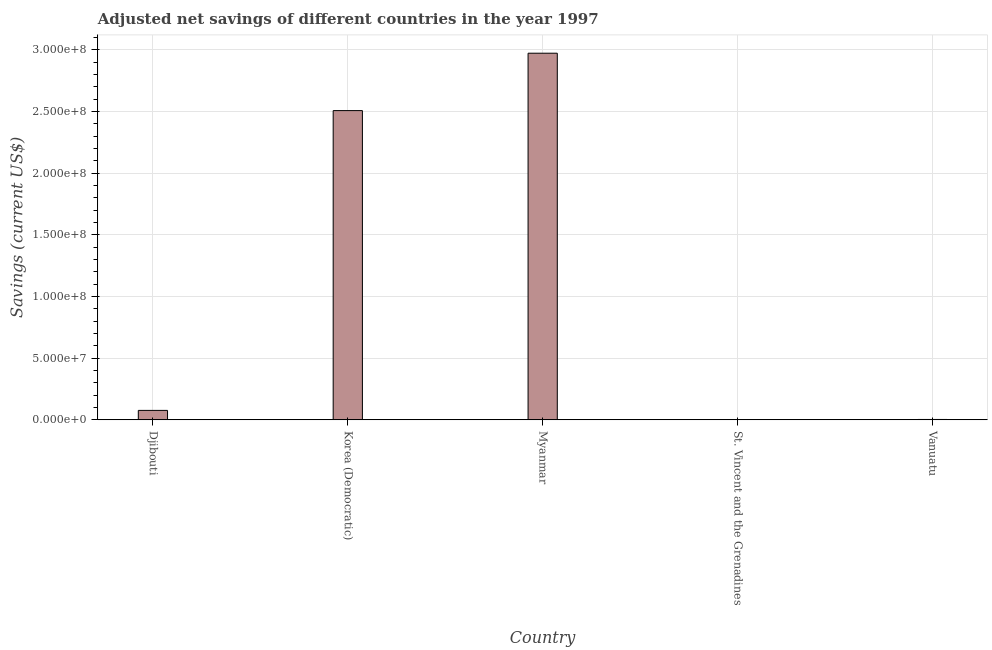What is the title of the graph?
Give a very brief answer. Adjusted net savings of different countries in the year 1997. What is the label or title of the Y-axis?
Your answer should be very brief. Savings (current US$). What is the adjusted net savings in Djibouti?
Give a very brief answer. 7.63e+06. Across all countries, what is the maximum adjusted net savings?
Provide a succinct answer. 2.97e+08. Across all countries, what is the minimum adjusted net savings?
Your response must be concise. 1.61e+05. In which country was the adjusted net savings maximum?
Your response must be concise. Myanmar. In which country was the adjusted net savings minimum?
Your answer should be compact. St. Vincent and the Grenadines. What is the sum of the adjusted net savings?
Provide a succinct answer. 5.56e+08. What is the difference between the adjusted net savings in Myanmar and St. Vincent and the Grenadines?
Your answer should be very brief. 2.97e+08. What is the average adjusted net savings per country?
Offer a very short reply. 1.11e+08. What is the median adjusted net savings?
Provide a short and direct response. 7.63e+06. What is the ratio of the adjusted net savings in Korea (Democratic) to that in Myanmar?
Your answer should be very brief. 0.84. What is the difference between the highest and the second highest adjusted net savings?
Offer a terse response. 4.65e+07. Is the sum of the adjusted net savings in Djibouti and St. Vincent and the Grenadines greater than the maximum adjusted net savings across all countries?
Give a very brief answer. No. What is the difference between the highest and the lowest adjusted net savings?
Your response must be concise. 2.97e+08. How many bars are there?
Offer a very short reply. 5. How many countries are there in the graph?
Give a very brief answer. 5. Are the values on the major ticks of Y-axis written in scientific E-notation?
Provide a succinct answer. Yes. What is the Savings (current US$) of Djibouti?
Give a very brief answer. 7.63e+06. What is the Savings (current US$) of Korea (Democratic)?
Ensure brevity in your answer.  2.51e+08. What is the Savings (current US$) of Myanmar?
Your answer should be very brief. 2.97e+08. What is the Savings (current US$) of St. Vincent and the Grenadines?
Make the answer very short. 1.61e+05. What is the Savings (current US$) in Vanuatu?
Offer a very short reply. 2.82e+05. What is the difference between the Savings (current US$) in Djibouti and Korea (Democratic)?
Provide a succinct answer. -2.43e+08. What is the difference between the Savings (current US$) in Djibouti and Myanmar?
Provide a short and direct response. -2.90e+08. What is the difference between the Savings (current US$) in Djibouti and St. Vincent and the Grenadines?
Your response must be concise. 7.46e+06. What is the difference between the Savings (current US$) in Djibouti and Vanuatu?
Ensure brevity in your answer.  7.34e+06. What is the difference between the Savings (current US$) in Korea (Democratic) and Myanmar?
Your answer should be very brief. -4.65e+07. What is the difference between the Savings (current US$) in Korea (Democratic) and St. Vincent and the Grenadines?
Ensure brevity in your answer.  2.50e+08. What is the difference between the Savings (current US$) in Korea (Democratic) and Vanuatu?
Give a very brief answer. 2.50e+08. What is the difference between the Savings (current US$) in Myanmar and St. Vincent and the Grenadines?
Give a very brief answer. 2.97e+08. What is the difference between the Savings (current US$) in Myanmar and Vanuatu?
Give a very brief answer. 2.97e+08. What is the difference between the Savings (current US$) in St. Vincent and the Grenadines and Vanuatu?
Offer a very short reply. -1.21e+05. What is the ratio of the Savings (current US$) in Djibouti to that in Korea (Democratic)?
Offer a very short reply. 0.03. What is the ratio of the Savings (current US$) in Djibouti to that in Myanmar?
Keep it short and to the point. 0.03. What is the ratio of the Savings (current US$) in Djibouti to that in St. Vincent and the Grenadines?
Make the answer very short. 47.24. What is the ratio of the Savings (current US$) in Djibouti to that in Vanuatu?
Offer a very short reply. 27. What is the ratio of the Savings (current US$) in Korea (Democratic) to that in Myanmar?
Your response must be concise. 0.84. What is the ratio of the Savings (current US$) in Korea (Democratic) to that in St. Vincent and the Grenadines?
Offer a very short reply. 1552.92. What is the ratio of the Savings (current US$) in Korea (Democratic) to that in Vanuatu?
Your answer should be compact. 887.42. What is the ratio of the Savings (current US$) in Myanmar to that in St. Vincent and the Grenadines?
Provide a short and direct response. 1841.14. What is the ratio of the Savings (current US$) in Myanmar to that in Vanuatu?
Make the answer very short. 1052.13. What is the ratio of the Savings (current US$) in St. Vincent and the Grenadines to that in Vanuatu?
Keep it short and to the point. 0.57. 